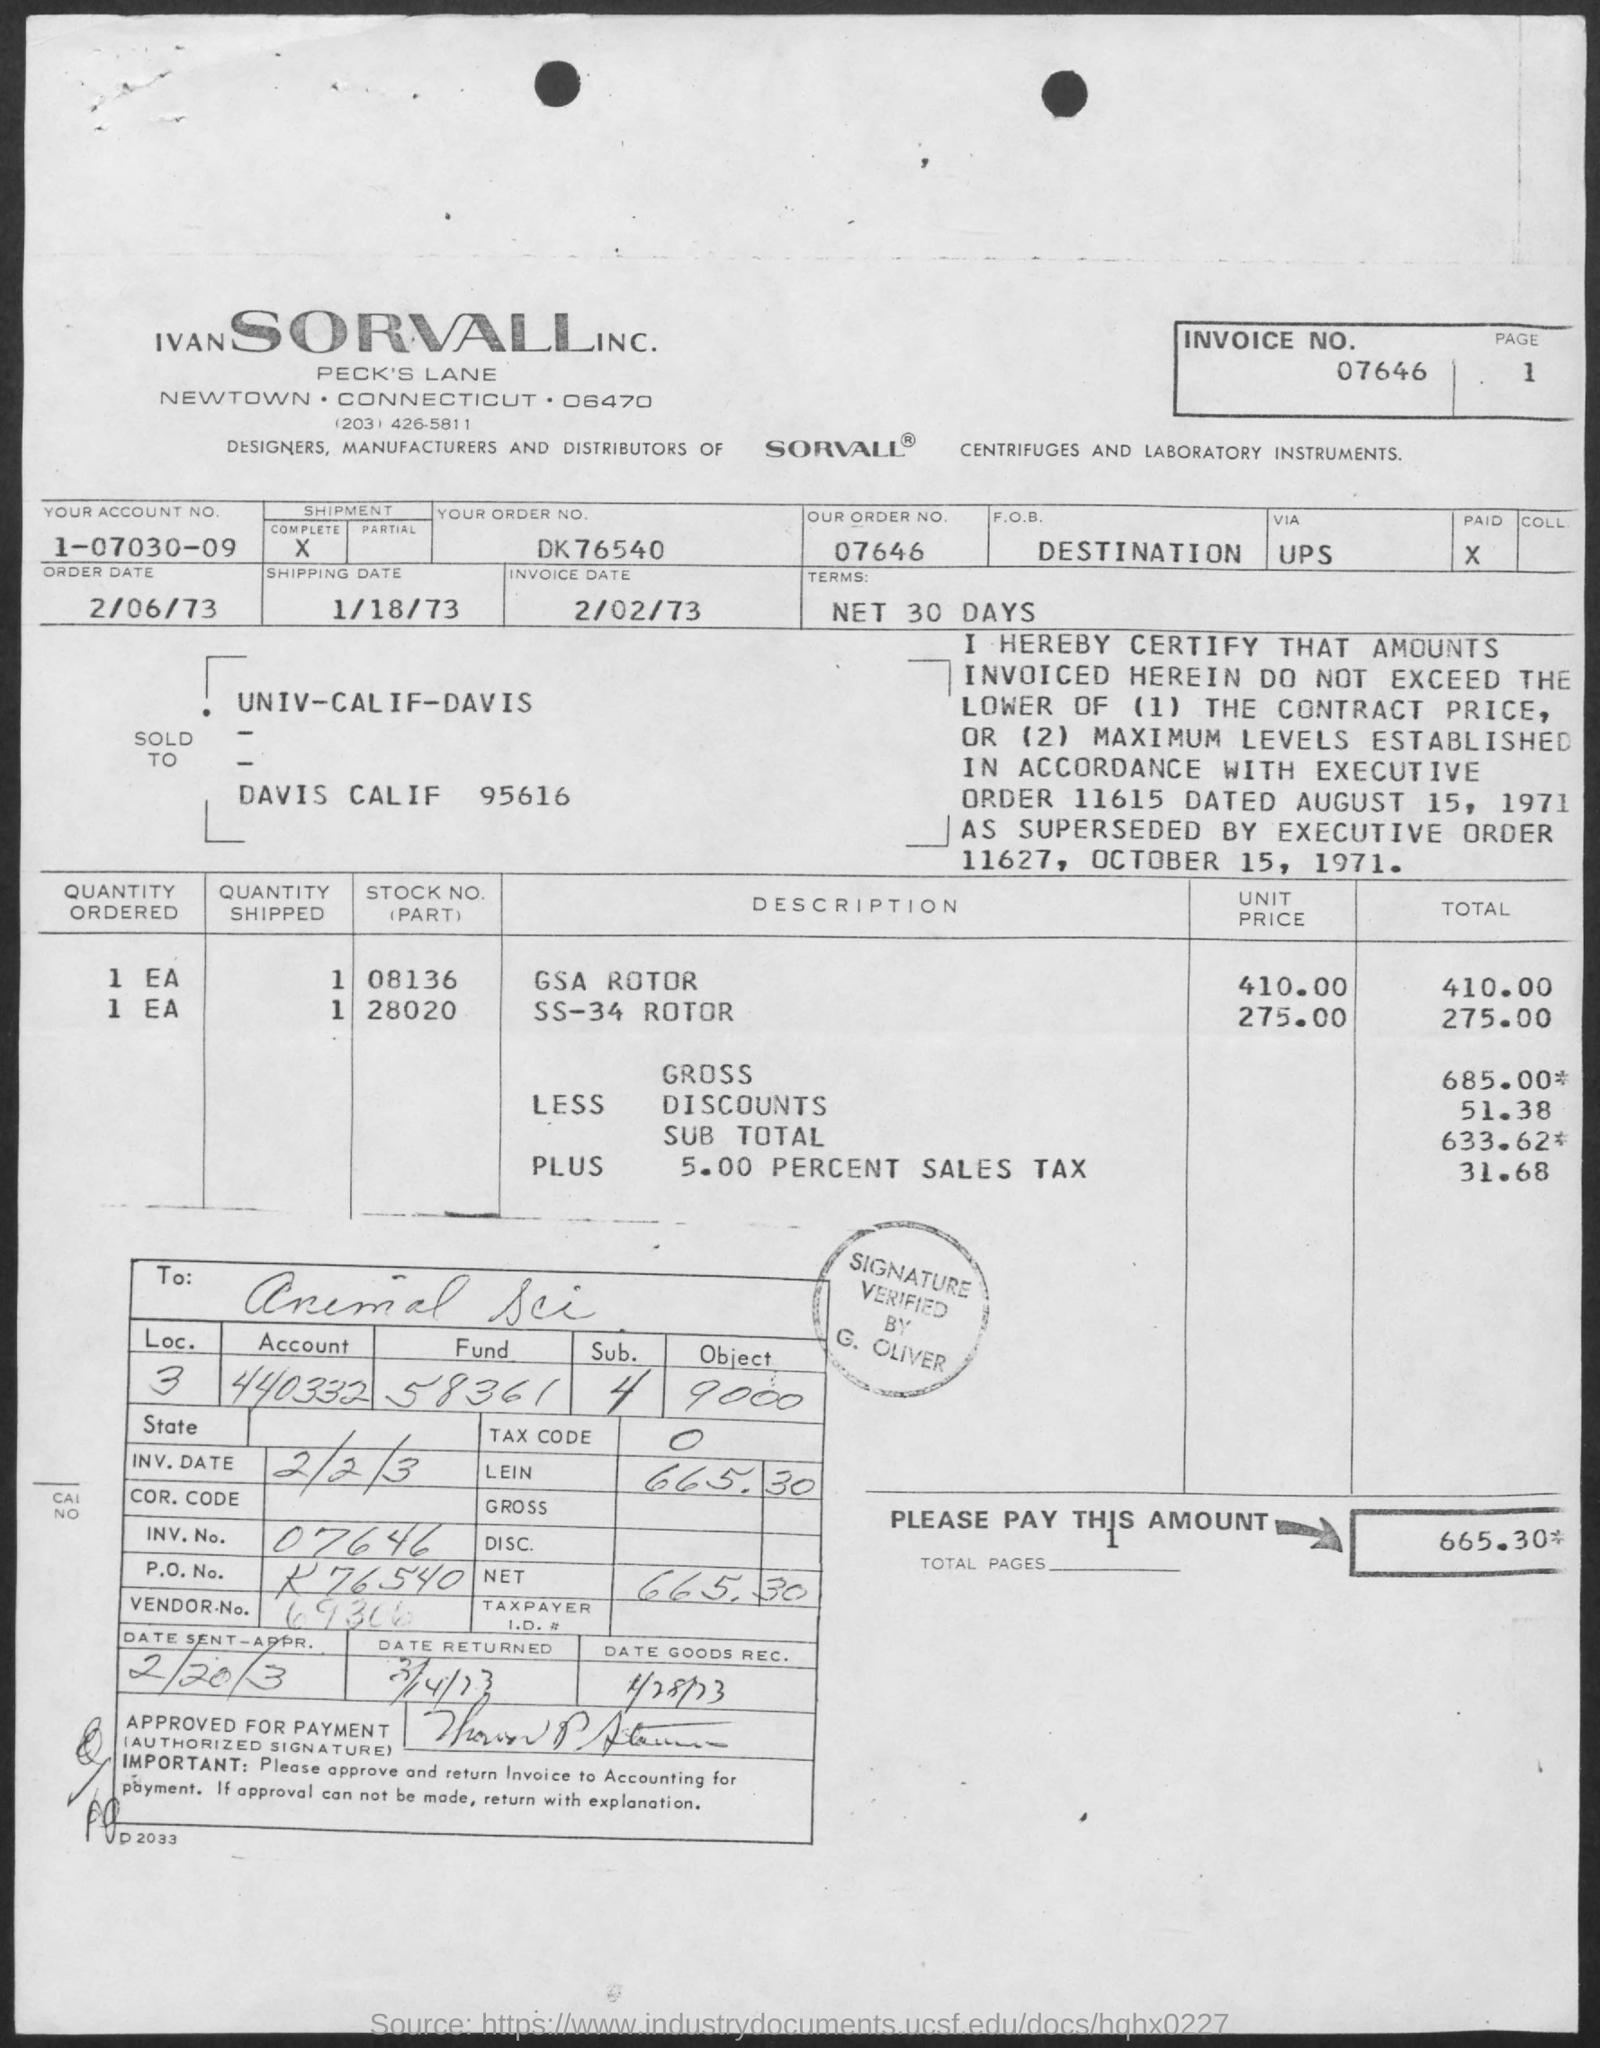Indicate a few pertinent items in this graphic. The invoice date is February 2, 1973. 